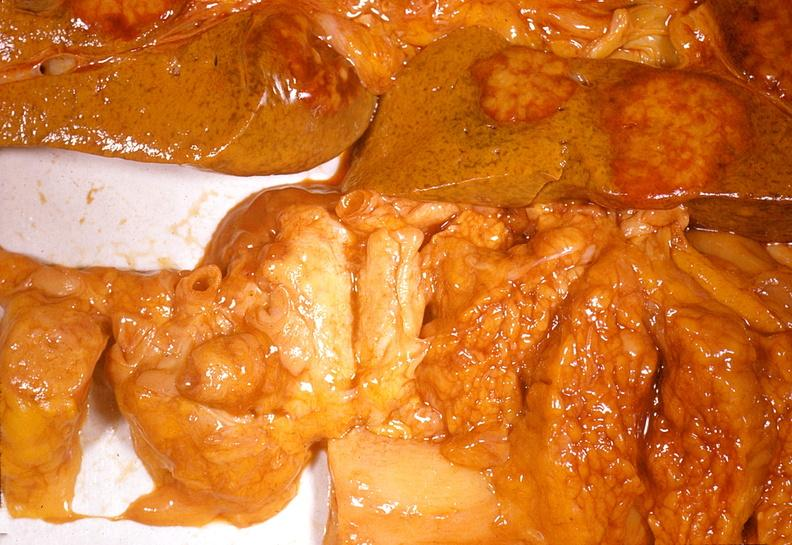what does this image show?
Answer the question using a single word or phrase. Adenocarcinoma 